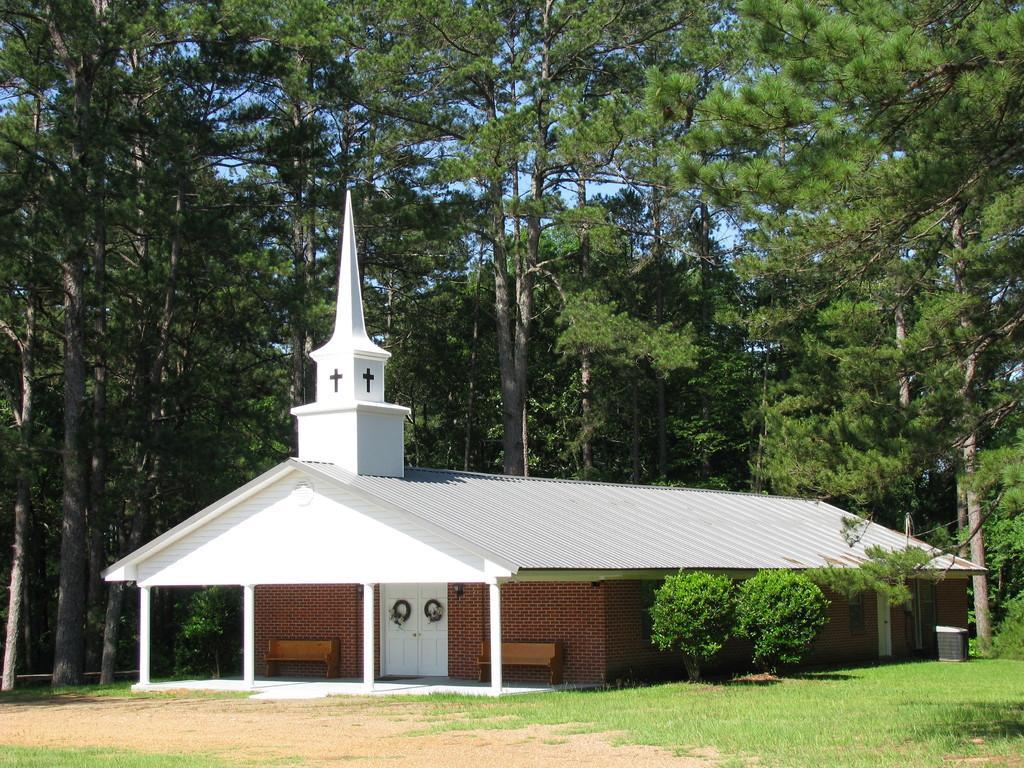Please provide a concise description of this image. In this image there is a house. Beside the house there are plants and a dustbin. At the bottom there is grass on the ground. Behind the house there are trees. At the top there is the sky. 